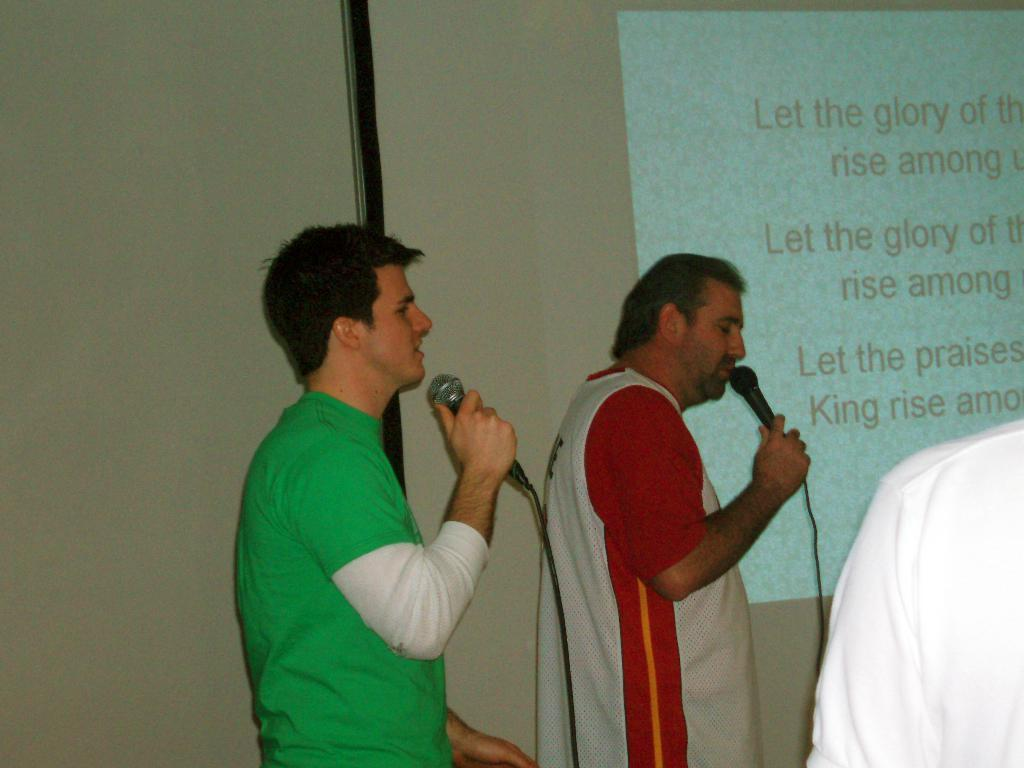What are the people in the image wearing? The people in the image are wearing clothes. What object is present for amplifying sound? There is a microphone in the image. What type of wire is visible in the image? There is a cable wire in the image. What is being projected in the image? There is a projected screen in the image. What surface is available for writing or displaying information? There is a whiteboard in the image. What type of structure is present in the background? There is a wall in the image. Can you see the ocean in the image? No, the ocean is not present in the image. What type of music is being played in the image? There is no music being played in the image; it only shows people, a microphone, and other objects. 